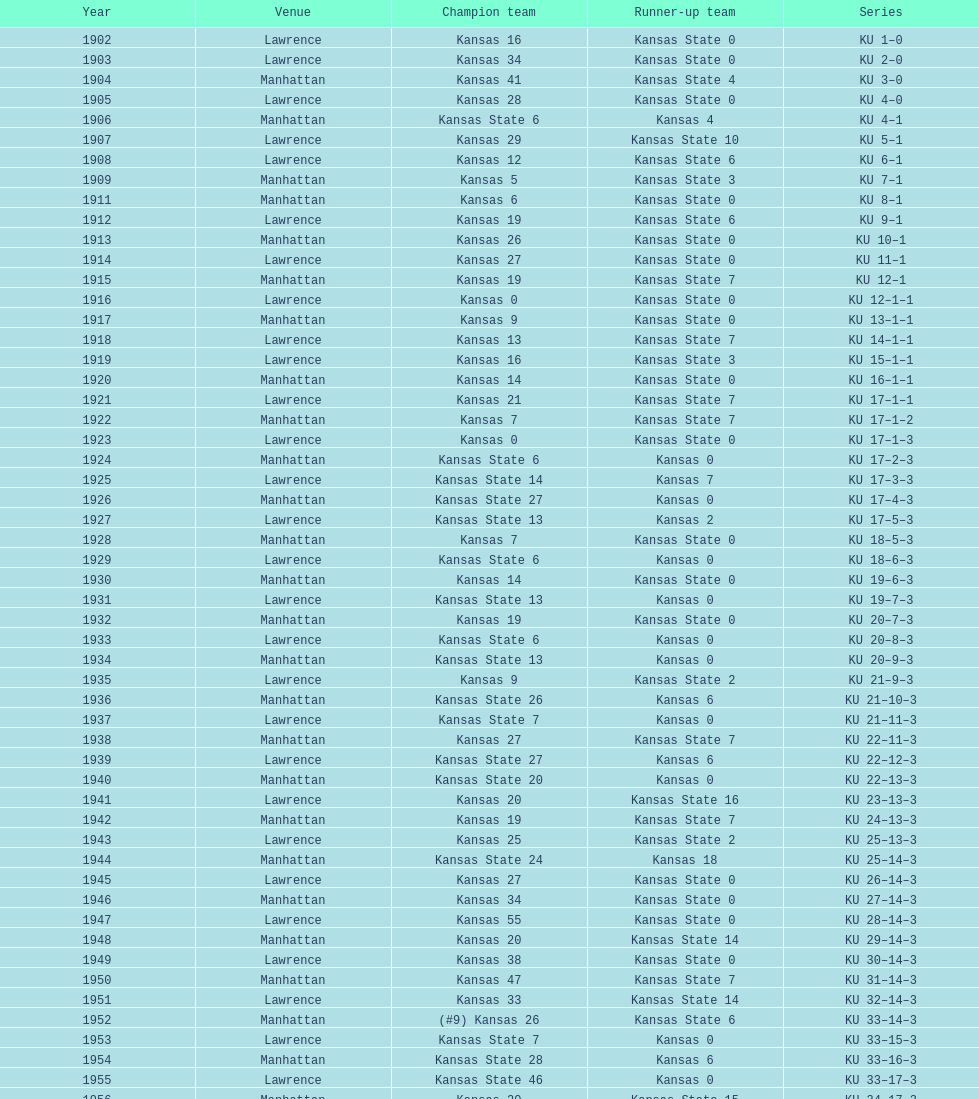When was the last time kansas state lost with 0 points in manhattan? 1964. 